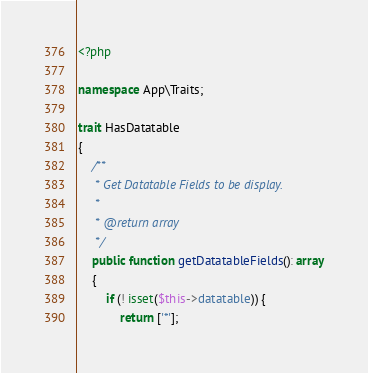<code> <loc_0><loc_0><loc_500><loc_500><_PHP_><?php

namespace App\Traits;

trait HasDatatable
{
    /**
     * Get Datatable Fields to be display.
     *
     * @return array
     */
    public function getDatatableFields(): array
    {
        if (! isset($this->datatable)) {
            return ['*'];</code> 